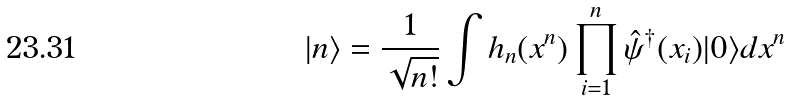Convert formula to latex. <formula><loc_0><loc_0><loc_500><loc_500>| n \rangle = \frac { 1 } { \sqrt { n ! } } \int h _ { n } ( x ^ { n } ) \prod _ { i = 1 } ^ { n } \hat { \psi } ^ { \dagger } ( x _ { i } ) | 0 \rangle d x ^ { n }</formula> 